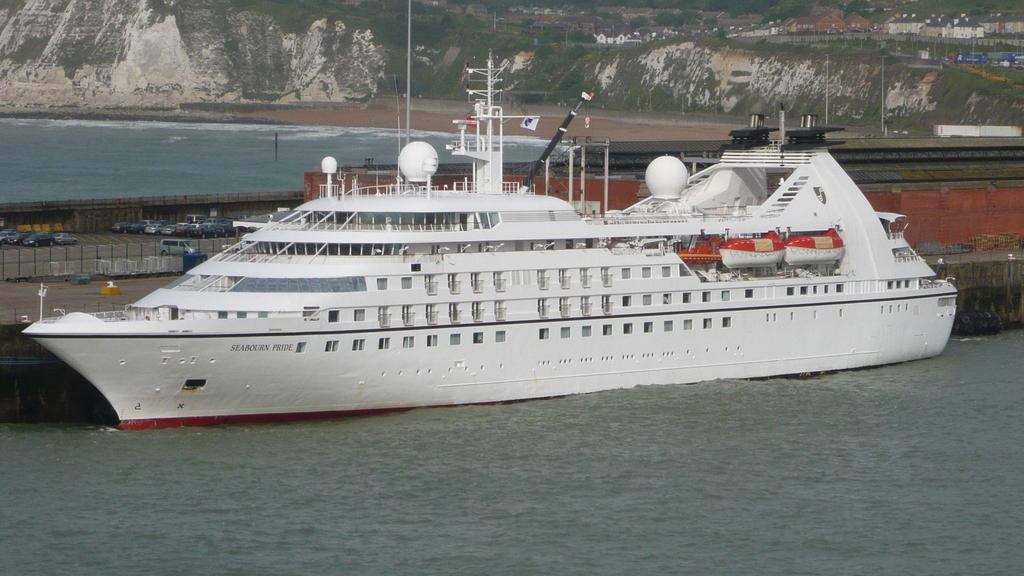Please provide a concise description of this image. In this image there is the sea, there is a ship on the sea, there are vehicles on the road, there is a fencing truncated towards the left of the image, there is rock truncated towards the left of the image, there are houses, there are objects on the ground, there are poles. 